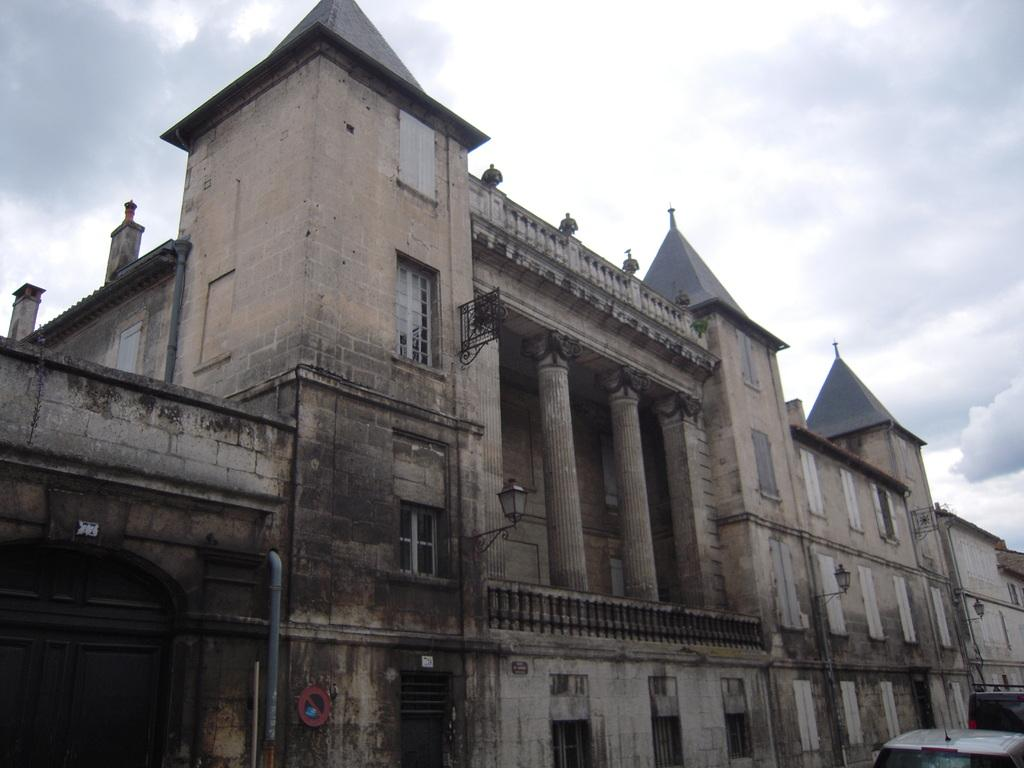What type of structure is in the image? There is an old building in the image. Where are the vehicles located in the image? The vehicles are in the right bottom corner of the image. What can be seen at the top of the image? The sky is visible at the top of the image. What type of insect is causing disgust in the image? There is no insect present in the image, and therefore no such reaction can be observed. 